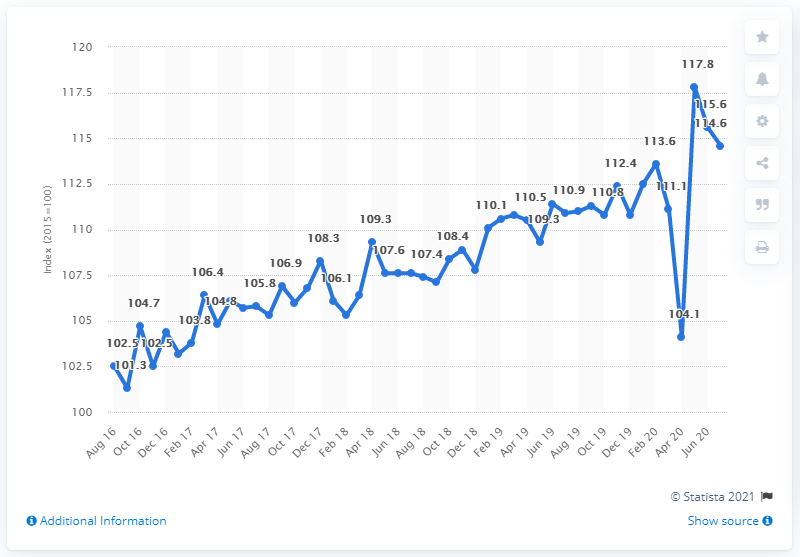Draw attention to some important aspects in this diagram. The value of retail trade sales in Germany in May 2020 was 117.8. 